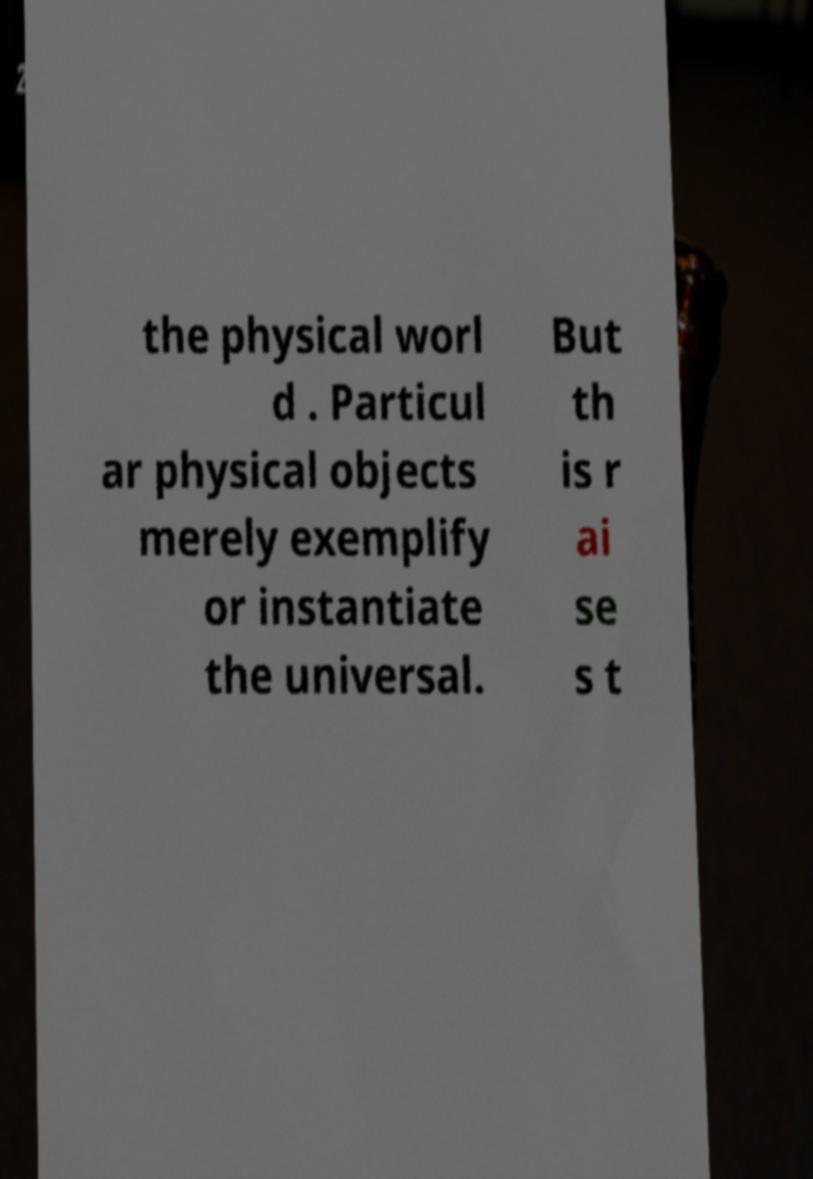For documentation purposes, I need the text within this image transcribed. Could you provide that? the physical worl d . Particul ar physical objects merely exemplify or instantiate the universal. But th is r ai se s t 